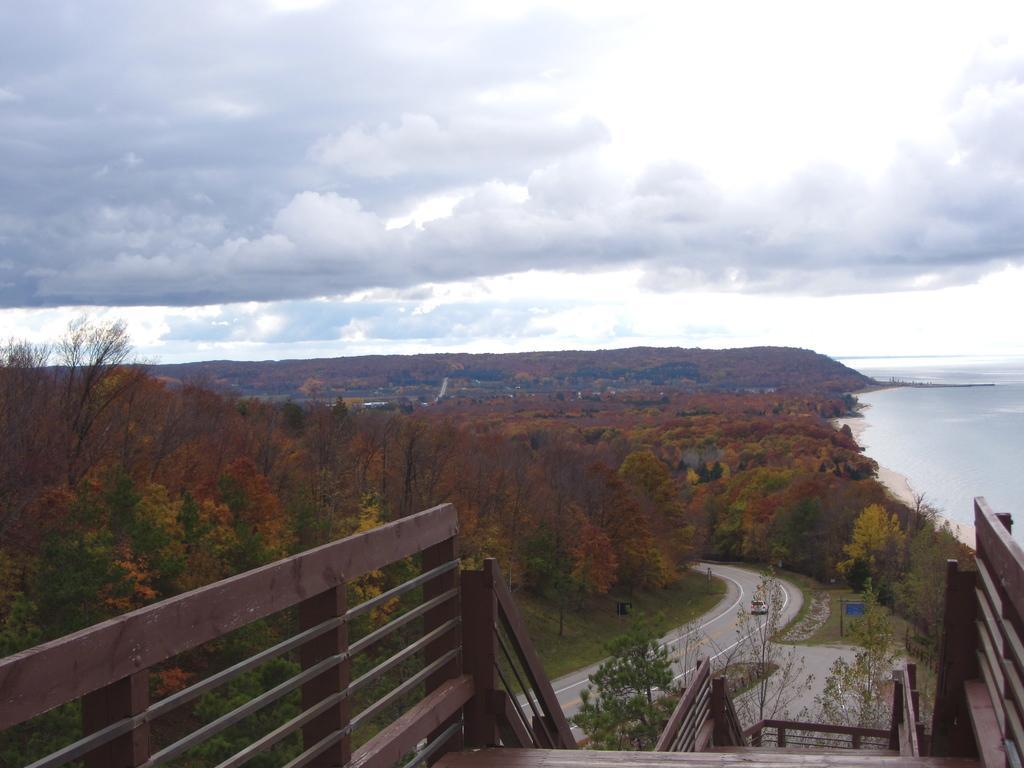In one or two sentences, can you explain what this image depicts? In this picture we can observe a railing which is in brown color. There is a road. There are some trees. On the right side there is an ocean. In the background we can observe a sky with some clouds. 